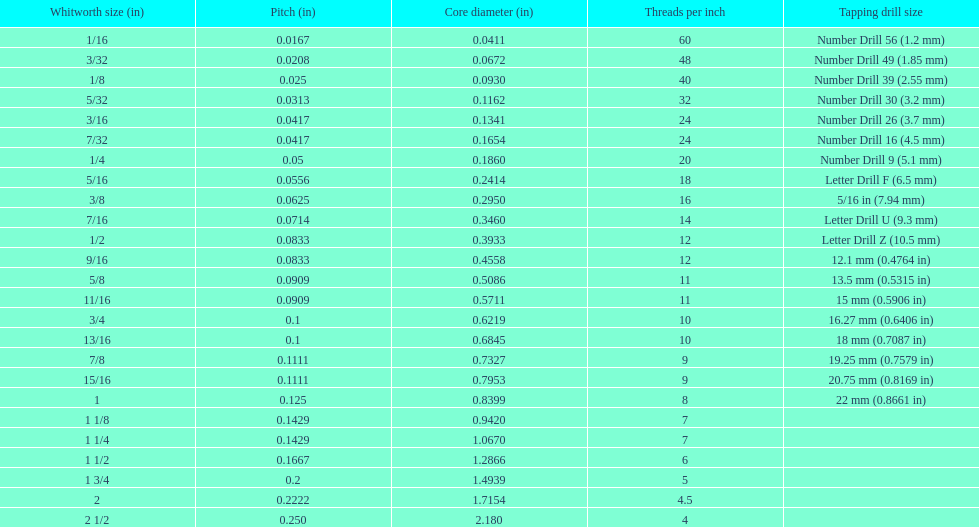What is the core diameter of the last whitworth thread size? 2.180. 